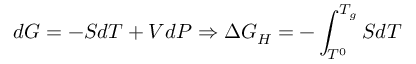<formula> <loc_0><loc_0><loc_500><loc_500>d G = - S d T + V d P \Rightarrow \Delta G _ { H } = - \int _ { T ^ { 0 } } ^ { T _ { g } } S d T</formula> 